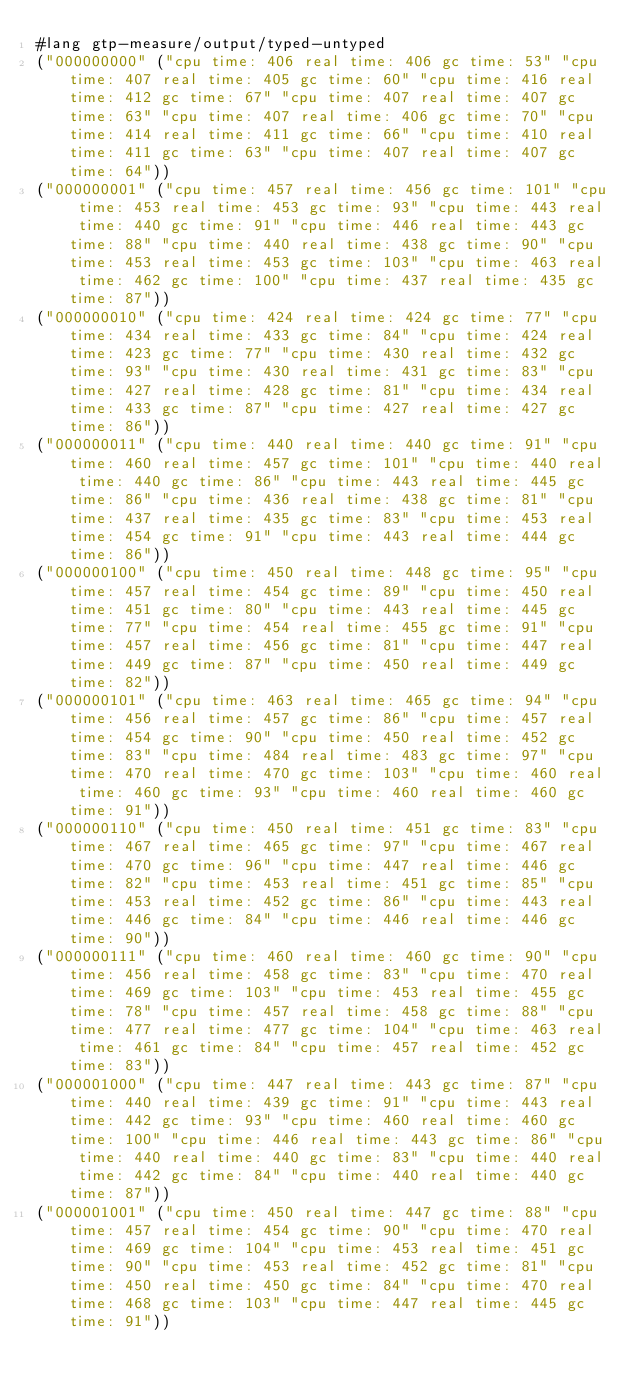<code> <loc_0><loc_0><loc_500><loc_500><_Racket_>#lang gtp-measure/output/typed-untyped
("000000000" ("cpu time: 406 real time: 406 gc time: 53" "cpu time: 407 real time: 405 gc time: 60" "cpu time: 416 real time: 412 gc time: 67" "cpu time: 407 real time: 407 gc time: 63" "cpu time: 407 real time: 406 gc time: 70" "cpu time: 414 real time: 411 gc time: 66" "cpu time: 410 real time: 411 gc time: 63" "cpu time: 407 real time: 407 gc time: 64"))
("000000001" ("cpu time: 457 real time: 456 gc time: 101" "cpu time: 453 real time: 453 gc time: 93" "cpu time: 443 real time: 440 gc time: 91" "cpu time: 446 real time: 443 gc time: 88" "cpu time: 440 real time: 438 gc time: 90" "cpu time: 453 real time: 453 gc time: 103" "cpu time: 463 real time: 462 gc time: 100" "cpu time: 437 real time: 435 gc time: 87"))
("000000010" ("cpu time: 424 real time: 424 gc time: 77" "cpu time: 434 real time: 433 gc time: 84" "cpu time: 424 real time: 423 gc time: 77" "cpu time: 430 real time: 432 gc time: 93" "cpu time: 430 real time: 431 gc time: 83" "cpu time: 427 real time: 428 gc time: 81" "cpu time: 434 real time: 433 gc time: 87" "cpu time: 427 real time: 427 gc time: 86"))
("000000011" ("cpu time: 440 real time: 440 gc time: 91" "cpu time: 460 real time: 457 gc time: 101" "cpu time: 440 real time: 440 gc time: 86" "cpu time: 443 real time: 445 gc time: 86" "cpu time: 436 real time: 438 gc time: 81" "cpu time: 437 real time: 435 gc time: 83" "cpu time: 453 real time: 454 gc time: 91" "cpu time: 443 real time: 444 gc time: 86"))
("000000100" ("cpu time: 450 real time: 448 gc time: 95" "cpu time: 457 real time: 454 gc time: 89" "cpu time: 450 real time: 451 gc time: 80" "cpu time: 443 real time: 445 gc time: 77" "cpu time: 454 real time: 455 gc time: 91" "cpu time: 457 real time: 456 gc time: 81" "cpu time: 447 real time: 449 gc time: 87" "cpu time: 450 real time: 449 gc time: 82"))
("000000101" ("cpu time: 463 real time: 465 gc time: 94" "cpu time: 456 real time: 457 gc time: 86" "cpu time: 457 real time: 454 gc time: 90" "cpu time: 450 real time: 452 gc time: 83" "cpu time: 484 real time: 483 gc time: 97" "cpu time: 470 real time: 470 gc time: 103" "cpu time: 460 real time: 460 gc time: 93" "cpu time: 460 real time: 460 gc time: 91"))
("000000110" ("cpu time: 450 real time: 451 gc time: 83" "cpu time: 467 real time: 465 gc time: 97" "cpu time: 467 real time: 470 gc time: 96" "cpu time: 447 real time: 446 gc time: 82" "cpu time: 453 real time: 451 gc time: 85" "cpu time: 453 real time: 452 gc time: 86" "cpu time: 443 real time: 446 gc time: 84" "cpu time: 446 real time: 446 gc time: 90"))
("000000111" ("cpu time: 460 real time: 460 gc time: 90" "cpu time: 456 real time: 458 gc time: 83" "cpu time: 470 real time: 469 gc time: 103" "cpu time: 453 real time: 455 gc time: 78" "cpu time: 457 real time: 458 gc time: 88" "cpu time: 477 real time: 477 gc time: 104" "cpu time: 463 real time: 461 gc time: 84" "cpu time: 457 real time: 452 gc time: 83"))
("000001000" ("cpu time: 447 real time: 443 gc time: 87" "cpu time: 440 real time: 439 gc time: 91" "cpu time: 443 real time: 442 gc time: 93" "cpu time: 460 real time: 460 gc time: 100" "cpu time: 446 real time: 443 gc time: 86" "cpu time: 440 real time: 440 gc time: 83" "cpu time: 440 real time: 442 gc time: 84" "cpu time: 440 real time: 440 gc time: 87"))
("000001001" ("cpu time: 450 real time: 447 gc time: 88" "cpu time: 457 real time: 454 gc time: 90" "cpu time: 470 real time: 469 gc time: 104" "cpu time: 453 real time: 451 gc time: 90" "cpu time: 453 real time: 452 gc time: 81" "cpu time: 450 real time: 450 gc time: 84" "cpu time: 470 real time: 468 gc time: 103" "cpu time: 447 real time: 445 gc time: 91"))</code> 